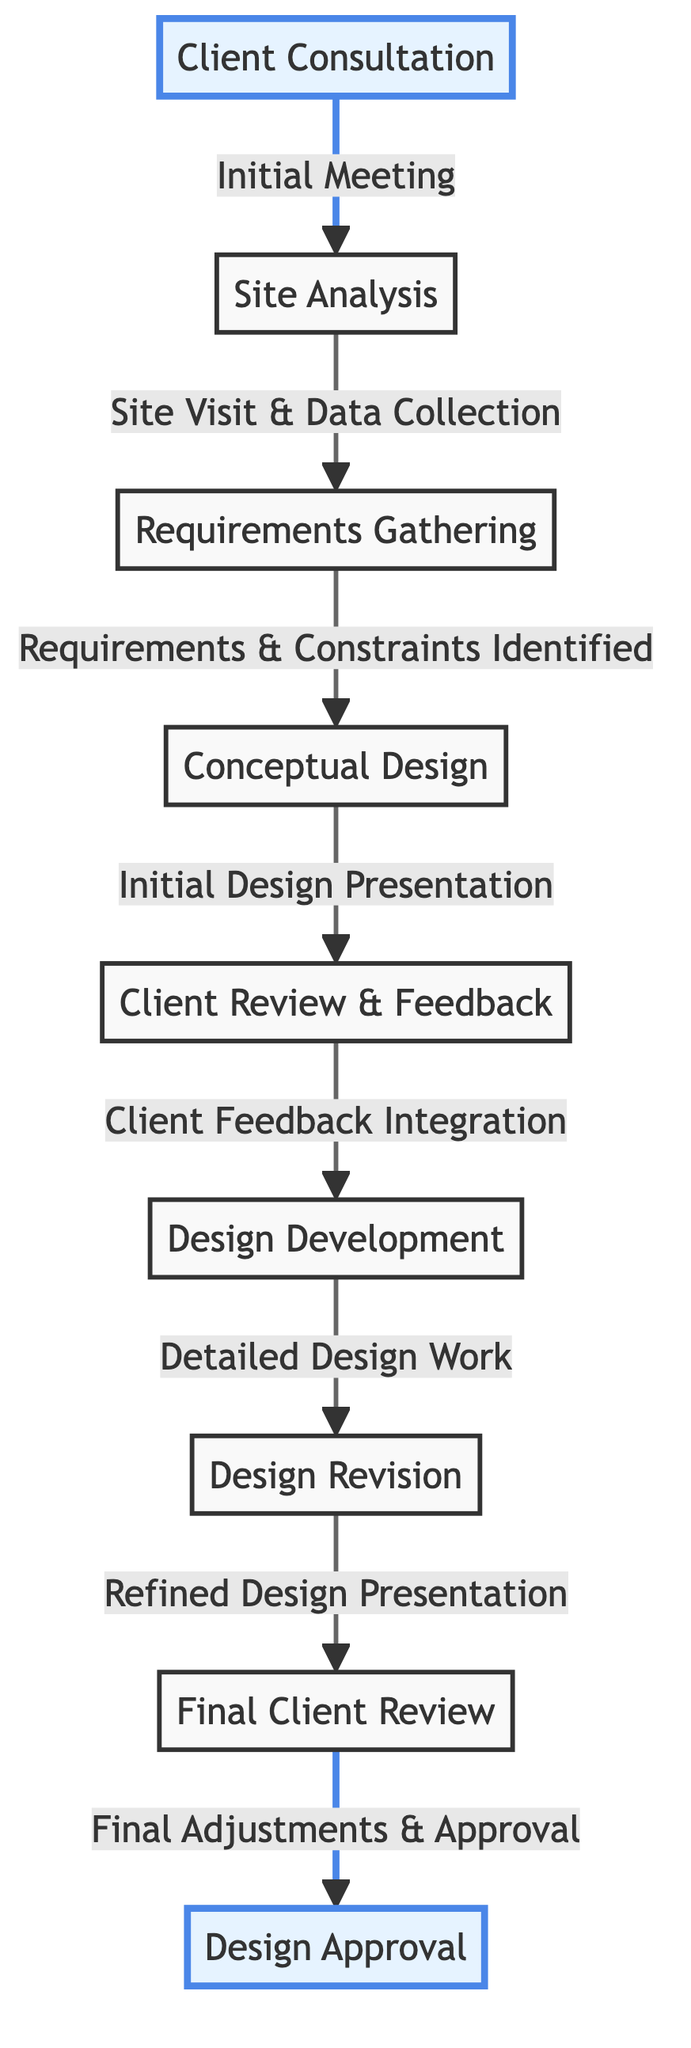What is the first node in the diagram? The first node in the diagram is highlighted in blue and represents the origin of the process, which is "Client Consultation."
Answer: Client Consultation How many nodes are present in the directed graph? By counting the unique stages from "Client Consultation" to "Design Approval," we have a total of 9 distinct nodes listed in the diagram.
Answer: 9 What relationship is shown between "Client Review & Feedback" and "Design Development"? The edge between these two nodes indicates that after "Client Review & Feedback," the next step involves "Client Feedback Integration," leading to "Design Development."
Answer: Client Feedback Integration Which node is the final step in the process? The last node in the progression of the directed graph, highlighted in blue, concludes the process with obtaining "Design Approval."
Answer: Design Approval What is the edge label connecting "Design Revision" and "Final Client Review"? The edge connecting these two nodes is labeled "Refined Design Presentation," indicating that after revisions, the design is presented again for final feedback.
Answer: Refined Design Presentation What is the total number of directed edges in the diagram? By examining the connections or edges between the nodes from start to finish, we identify a total of 8 directed edges throughout the diagram.
Answer: 8 Which node follows "Requirements Gathering"? According to the directional flow of the graph, the next step that follows "Requirements Gathering" is "Conceptual Design."
Answer: Conceptual Design What is the relationship labeled between "Conceptual Design" and "Client Review & Feedback"? The relationship between these two nodes is specified as "Initial Design Presentation," indicating the moment the initial design is shared with the client.
Answer: Initial Design Presentation What action occurs between "Client Review & Feedback" and "Design Development"? The process indicates that "Client Feedback Integration" is the action that transitions from "Client Review & Feedback" to "Design Development."
Answer: Client Feedback Integration 